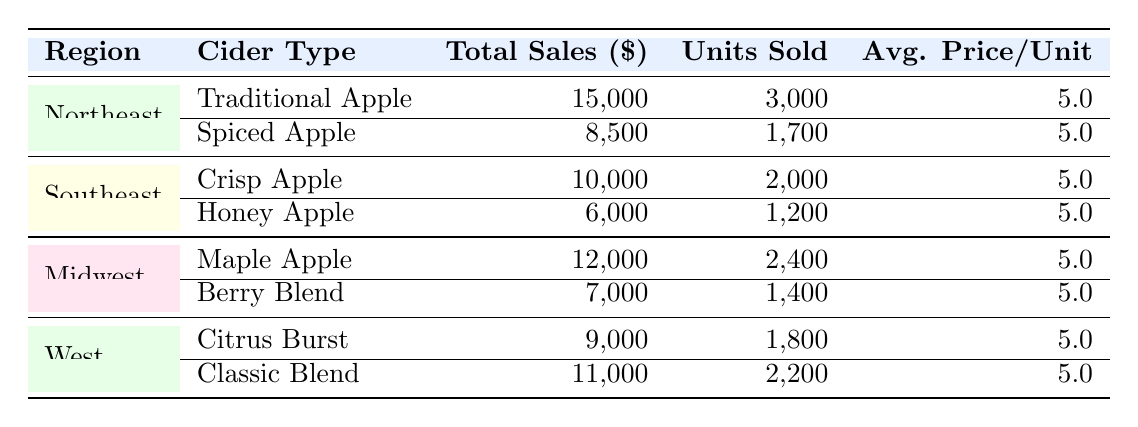What is the total sales for Traditional Apple cider in the Northeast region? The table indicates that the total sales for Traditional Apple cider in the Northeast region are listed directly as 15,000.
Answer: 15,000 Which cider type in the Southeast region had the highest units sold? In the Southeast region, Crisp Apple cider had 2,000 units sold, while Honey Apple had 1,200 units sold. Therefore, Crisp Apple has the highest units sold.
Answer: Crisp Apple What is the average price per unit for Maple Apple cider? The table shows that the Average Price Per Unit for Maple Apple cider is 5.0, which is consistent with the pricing for all ciders listed.
Answer: 5.0 Which region had the lowest total sales among all cider types? By examining the total sales for each region: Northeast has 15,000 + 8,500 = 23,500; Southeast has 10,000 + 6,000 = 16,000; Midwest has 12,000 + 7,000 = 19,000; West has 9,000 + 11,000 = 20,000. The Southeast region has the lowest total sales.
Answer: Southeast How much more total sales did the Northeast region generate compared to the Midwest region? Total sales for the Northeast region are 23,500, and for the Midwest, they are 19,000. The difference is 23,500 - 19,000 = 4,500.
Answer: 4,500 Is it true that the Classic Blend cider had sales greater than the total sales of Honey Apple cider? The total sales for Classic Blend cider is 11,000, while the total sales for Honey Apple cider is 6,000. Therefore, it's true that Classic Blend had greater sales.
Answer: Yes What is the total number of units sold for the Spiced Apple cider and the Berry Blend cider combined? The units sold for Spiced Apple cider are 1,700, and for Berry Blend cider, they are 1,400. Combining these gives 1,700 + 1,400 = 3,100 units sold.
Answer: 3,100 Which cider had higher total sales: Citrus Burst or Spiced Apple? The total sales for Citrus Burst cider is 9,000, while for Spiced Apple cider, it is 8,500. Since 9,000 is greater than 8,500, Citrus Burst had higher total sales.
Answer: Citrus Burst What was the total sales across all regions for all cider types? The total sales can be calculated by summing the total sales of all ciders across all regions: 23,500 (Northeast) + 16,000 (Southeast) + 19,000 (Midwest) + 20,000 (West) = 78,500.
Answer: 78,500 